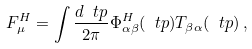Convert formula to latex. <formula><loc_0><loc_0><loc_500><loc_500>F ^ { H } _ { \mu } = \int \frac { d \ t p } { 2 \pi } \Phi ^ { H } _ { \alpha \beta } ( \ t p ) T _ { \beta \alpha } ( \ t p ) \, ,</formula> 